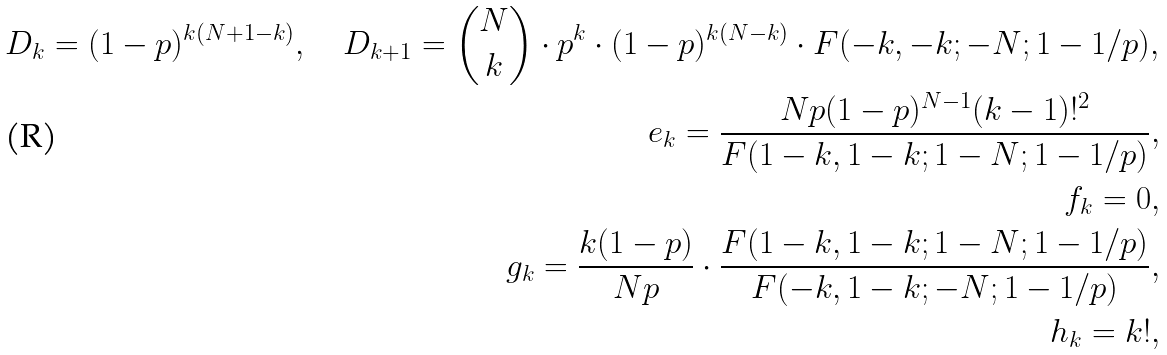Convert formula to latex. <formula><loc_0><loc_0><loc_500><loc_500>D _ { k } = ( 1 - p ) ^ { k ( N + 1 - k ) } , \quad D _ { k + 1 } = { N \choose k } \cdot p ^ { k } \cdot ( 1 - p ) ^ { k ( N - k ) } \cdot F ( - k , - k ; - N ; 1 - 1 / p ) , \\ e _ { k } = \frac { N p ( 1 - p ) ^ { N - 1 } ( k - 1 ) ! ^ { 2 } } { F ( 1 - k , 1 - k ; 1 - N ; 1 - 1 / p ) } , \\ f _ { k } = 0 , \\ g _ { k } = \frac { k ( 1 - p ) } { N p } \cdot \frac { F ( 1 - k , 1 - k ; 1 - N ; 1 - 1 / p ) } { F ( - k , 1 - k ; - N ; 1 - 1 / p ) } , \\ h _ { k } = k ! ,</formula> 